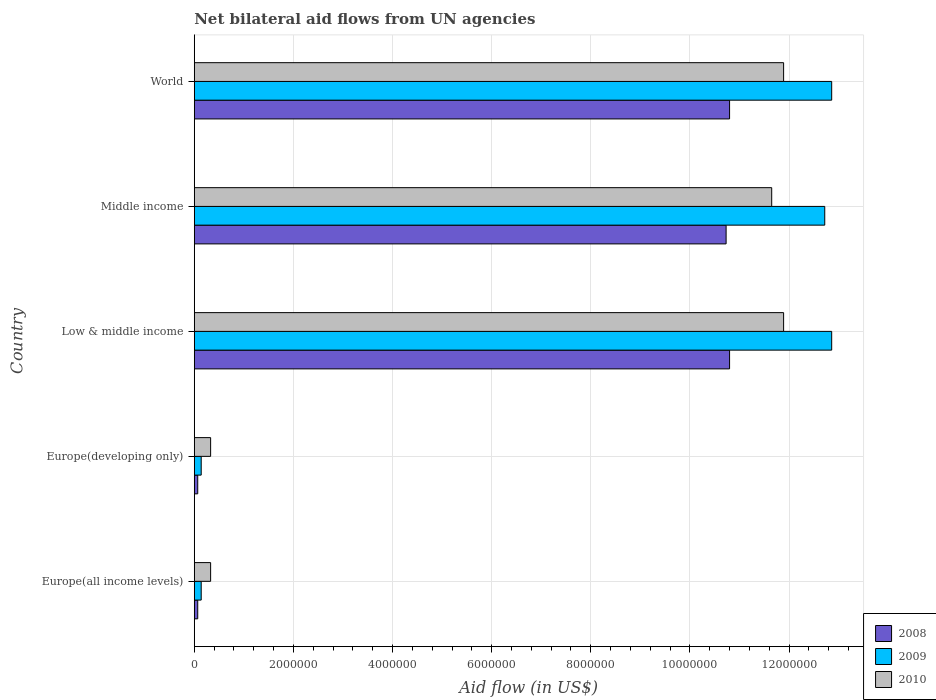Are the number of bars per tick equal to the number of legend labels?
Provide a short and direct response. Yes. How many bars are there on the 2nd tick from the top?
Offer a very short reply. 3. What is the label of the 5th group of bars from the top?
Make the answer very short. Europe(all income levels). Across all countries, what is the maximum net bilateral aid flow in 2008?
Your answer should be very brief. 1.08e+07. Across all countries, what is the minimum net bilateral aid flow in 2008?
Your answer should be very brief. 7.00e+04. In which country was the net bilateral aid flow in 2010 minimum?
Give a very brief answer. Europe(all income levels). What is the total net bilateral aid flow in 2010 in the graph?
Your answer should be very brief. 3.61e+07. What is the difference between the net bilateral aid flow in 2009 in Europe(all income levels) and that in Middle income?
Ensure brevity in your answer.  -1.26e+07. What is the difference between the net bilateral aid flow in 2010 in Middle income and the net bilateral aid flow in 2008 in Europe(all income levels)?
Your response must be concise. 1.16e+07. What is the average net bilateral aid flow in 2009 per country?
Make the answer very short. 7.74e+06. What is the ratio of the net bilateral aid flow in 2009 in Europe(all income levels) to that in World?
Provide a succinct answer. 0.01. Is the difference between the net bilateral aid flow in 2008 in Low & middle income and Middle income greater than the difference between the net bilateral aid flow in 2009 in Low & middle income and Middle income?
Your answer should be very brief. No. What is the difference between the highest and the lowest net bilateral aid flow in 2010?
Provide a succinct answer. 1.16e+07. How many bars are there?
Provide a short and direct response. 15. Are all the bars in the graph horizontal?
Your answer should be very brief. Yes. Does the graph contain grids?
Give a very brief answer. Yes. Where does the legend appear in the graph?
Your answer should be compact. Bottom right. What is the title of the graph?
Your answer should be very brief. Net bilateral aid flows from UN agencies. Does "1972" appear as one of the legend labels in the graph?
Your answer should be compact. No. What is the label or title of the X-axis?
Make the answer very short. Aid flow (in US$). What is the Aid flow (in US$) in 2008 in Europe(all income levels)?
Your answer should be very brief. 7.00e+04. What is the Aid flow (in US$) in 2009 in Europe(all income levels)?
Provide a succinct answer. 1.40e+05. What is the Aid flow (in US$) of 2010 in Europe(all income levels)?
Provide a short and direct response. 3.30e+05. What is the Aid flow (in US$) of 2008 in Europe(developing only)?
Your answer should be very brief. 7.00e+04. What is the Aid flow (in US$) in 2009 in Europe(developing only)?
Offer a terse response. 1.40e+05. What is the Aid flow (in US$) in 2008 in Low & middle income?
Keep it short and to the point. 1.08e+07. What is the Aid flow (in US$) of 2009 in Low & middle income?
Your answer should be compact. 1.29e+07. What is the Aid flow (in US$) of 2010 in Low & middle income?
Give a very brief answer. 1.19e+07. What is the Aid flow (in US$) in 2008 in Middle income?
Your answer should be very brief. 1.07e+07. What is the Aid flow (in US$) of 2009 in Middle income?
Provide a succinct answer. 1.27e+07. What is the Aid flow (in US$) in 2010 in Middle income?
Offer a very short reply. 1.16e+07. What is the Aid flow (in US$) of 2008 in World?
Provide a short and direct response. 1.08e+07. What is the Aid flow (in US$) of 2009 in World?
Provide a short and direct response. 1.29e+07. What is the Aid flow (in US$) in 2010 in World?
Your answer should be very brief. 1.19e+07. Across all countries, what is the maximum Aid flow (in US$) of 2008?
Your response must be concise. 1.08e+07. Across all countries, what is the maximum Aid flow (in US$) in 2009?
Give a very brief answer. 1.29e+07. Across all countries, what is the maximum Aid flow (in US$) in 2010?
Your answer should be compact. 1.19e+07. Across all countries, what is the minimum Aid flow (in US$) in 2008?
Make the answer very short. 7.00e+04. Across all countries, what is the minimum Aid flow (in US$) of 2010?
Make the answer very short. 3.30e+05. What is the total Aid flow (in US$) in 2008 in the graph?
Make the answer very short. 3.25e+07. What is the total Aid flow (in US$) in 2009 in the graph?
Offer a very short reply. 3.87e+07. What is the total Aid flow (in US$) of 2010 in the graph?
Your answer should be very brief. 3.61e+07. What is the difference between the Aid flow (in US$) of 2009 in Europe(all income levels) and that in Europe(developing only)?
Give a very brief answer. 0. What is the difference between the Aid flow (in US$) of 2008 in Europe(all income levels) and that in Low & middle income?
Provide a short and direct response. -1.07e+07. What is the difference between the Aid flow (in US$) in 2009 in Europe(all income levels) and that in Low & middle income?
Offer a terse response. -1.27e+07. What is the difference between the Aid flow (in US$) in 2010 in Europe(all income levels) and that in Low & middle income?
Your answer should be compact. -1.16e+07. What is the difference between the Aid flow (in US$) in 2008 in Europe(all income levels) and that in Middle income?
Give a very brief answer. -1.07e+07. What is the difference between the Aid flow (in US$) in 2009 in Europe(all income levels) and that in Middle income?
Make the answer very short. -1.26e+07. What is the difference between the Aid flow (in US$) in 2010 in Europe(all income levels) and that in Middle income?
Give a very brief answer. -1.13e+07. What is the difference between the Aid flow (in US$) in 2008 in Europe(all income levels) and that in World?
Your answer should be compact. -1.07e+07. What is the difference between the Aid flow (in US$) of 2009 in Europe(all income levels) and that in World?
Offer a very short reply. -1.27e+07. What is the difference between the Aid flow (in US$) of 2010 in Europe(all income levels) and that in World?
Ensure brevity in your answer.  -1.16e+07. What is the difference between the Aid flow (in US$) of 2008 in Europe(developing only) and that in Low & middle income?
Keep it short and to the point. -1.07e+07. What is the difference between the Aid flow (in US$) of 2009 in Europe(developing only) and that in Low & middle income?
Give a very brief answer. -1.27e+07. What is the difference between the Aid flow (in US$) of 2010 in Europe(developing only) and that in Low & middle income?
Offer a very short reply. -1.16e+07. What is the difference between the Aid flow (in US$) in 2008 in Europe(developing only) and that in Middle income?
Your answer should be compact. -1.07e+07. What is the difference between the Aid flow (in US$) in 2009 in Europe(developing only) and that in Middle income?
Ensure brevity in your answer.  -1.26e+07. What is the difference between the Aid flow (in US$) in 2010 in Europe(developing only) and that in Middle income?
Provide a short and direct response. -1.13e+07. What is the difference between the Aid flow (in US$) in 2008 in Europe(developing only) and that in World?
Keep it short and to the point. -1.07e+07. What is the difference between the Aid flow (in US$) of 2009 in Europe(developing only) and that in World?
Ensure brevity in your answer.  -1.27e+07. What is the difference between the Aid flow (in US$) in 2010 in Europe(developing only) and that in World?
Your answer should be very brief. -1.16e+07. What is the difference between the Aid flow (in US$) of 2010 in Low & middle income and that in Middle income?
Offer a terse response. 2.40e+05. What is the difference between the Aid flow (in US$) of 2009 in Low & middle income and that in World?
Make the answer very short. 0. What is the difference between the Aid flow (in US$) in 2010 in Low & middle income and that in World?
Offer a very short reply. 0. What is the difference between the Aid flow (in US$) in 2009 in Middle income and that in World?
Offer a terse response. -1.40e+05. What is the difference between the Aid flow (in US$) of 2008 in Europe(all income levels) and the Aid flow (in US$) of 2010 in Europe(developing only)?
Provide a succinct answer. -2.60e+05. What is the difference between the Aid flow (in US$) in 2009 in Europe(all income levels) and the Aid flow (in US$) in 2010 in Europe(developing only)?
Provide a short and direct response. -1.90e+05. What is the difference between the Aid flow (in US$) of 2008 in Europe(all income levels) and the Aid flow (in US$) of 2009 in Low & middle income?
Give a very brief answer. -1.28e+07. What is the difference between the Aid flow (in US$) in 2008 in Europe(all income levels) and the Aid flow (in US$) in 2010 in Low & middle income?
Your answer should be very brief. -1.18e+07. What is the difference between the Aid flow (in US$) of 2009 in Europe(all income levels) and the Aid flow (in US$) of 2010 in Low & middle income?
Give a very brief answer. -1.18e+07. What is the difference between the Aid flow (in US$) in 2008 in Europe(all income levels) and the Aid flow (in US$) in 2009 in Middle income?
Provide a succinct answer. -1.26e+07. What is the difference between the Aid flow (in US$) in 2008 in Europe(all income levels) and the Aid flow (in US$) in 2010 in Middle income?
Give a very brief answer. -1.16e+07. What is the difference between the Aid flow (in US$) of 2009 in Europe(all income levels) and the Aid flow (in US$) of 2010 in Middle income?
Provide a succinct answer. -1.15e+07. What is the difference between the Aid flow (in US$) in 2008 in Europe(all income levels) and the Aid flow (in US$) in 2009 in World?
Give a very brief answer. -1.28e+07. What is the difference between the Aid flow (in US$) in 2008 in Europe(all income levels) and the Aid flow (in US$) in 2010 in World?
Provide a short and direct response. -1.18e+07. What is the difference between the Aid flow (in US$) in 2009 in Europe(all income levels) and the Aid flow (in US$) in 2010 in World?
Your answer should be compact. -1.18e+07. What is the difference between the Aid flow (in US$) of 2008 in Europe(developing only) and the Aid flow (in US$) of 2009 in Low & middle income?
Keep it short and to the point. -1.28e+07. What is the difference between the Aid flow (in US$) in 2008 in Europe(developing only) and the Aid flow (in US$) in 2010 in Low & middle income?
Ensure brevity in your answer.  -1.18e+07. What is the difference between the Aid flow (in US$) in 2009 in Europe(developing only) and the Aid flow (in US$) in 2010 in Low & middle income?
Your answer should be very brief. -1.18e+07. What is the difference between the Aid flow (in US$) of 2008 in Europe(developing only) and the Aid flow (in US$) of 2009 in Middle income?
Keep it short and to the point. -1.26e+07. What is the difference between the Aid flow (in US$) of 2008 in Europe(developing only) and the Aid flow (in US$) of 2010 in Middle income?
Your answer should be compact. -1.16e+07. What is the difference between the Aid flow (in US$) in 2009 in Europe(developing only) and the Aid flow (in US$) in 2010 in Middle income?
Your response must be concise. -1.15e+07. What is the difference between the Aid flow (in US$) of 2008 in Europe(developing only) and the Aid flow (in US$) of 2009 in World?
Make the answer very short. -1.28e+07. What is the difference between the Aid flow (in US$) of 2008 in Europe(developing only) and the Aid flow (in US$) of 2010 in World?
Make the answer very short. -1.18e+07. What is the difference between the Aid flow (in US$) in 2009 in Europe(developing only) and the Aid flow (in US$) in 2010 in World?
Provide a succinct answer. -1.18e+07. What is the difference between the Aid flow (in US$) of 2008 in Low & middle income and the Aid flow (in US$) of 2009 in Middle income?
Your response must be concise. -1.92e+06. What is the difference between the Aid flow (in US$) of 2008 in Low & middle income and the Aid flow (in US$) of 2010 in Middle income?
Your answer should be compact. -8.50e+05. What is the difference between the Aid flow (in US$) of 2009 in Low & middle income and the Aid flow (in US$) of 2010 in Middle income?
Offer a terse response. 1.21e+06. What is the difference between the Aid flow (in US$) in 2008 in Low & middle income and the Aid flow (in US$) in 2009 in World?
Provide a succinct answer. -2.06e+06. What is the difference between the Aid flow (in US$) in 2008 in Low & middle income and the Aid flow (in US$) in 2010 in World?
Provide a succinct answer. -1.09e+06. What is the difference between the Aid flow (in US$) in 2009 in Low & middle income and the Aid flow (in US$) in 2010 in World?
Offer a terse response. 9.70e+05. What is the difference between the Aid flow (in US$) of 2008 in Middle income and the Aid flow (in US$) of 2009 in World?
Make the answer very short. -2.13e+06. What is the difference between the Aid flow (in US$) of 2008 in Middle income and the Aid flow (in US$) of 2010 in World?
Your answer should be very brief. -1.16e+06. What is the difference between the Aid flow (in US$) of 2009 in Middle income and the Aid flow (in US$) of 2010 in World?
Give a very brief answer. 8.30e+05. What is the average Aid flow (in US$) of 2008 per country?
Provide a short and direct response. 6.49e+06. What is the average Aid flow (in US$) in 2009 per country?
Your answer should be very brief. 7.74e+06. What is the average Aid flow (in US$) of 2010 per country?
Offer a very short reply. 7.22e+06. What is the difference between the Aid flow (in US$) in 2008 and Aid flow (in US$) in 2009 in Europe(all income levels)?
Offer a very short reply. -7.00e+04. What is the difference between the Aid flow (in US$) of 2008 and Aid flow (in US$) of 2010 in Europe(all income levels)?
Make the answer very short. -2.60e+05. What is the difference between the Aid flow (in US$) of 2008 and Aid flow (in US$) of 2009 in Europe(developing only)?
Your response must be concise. -7.00e+04. What is the difference between the Aid flow (in US$) of 2008 and Aid flow (in US$) of 2009 in Low & middle income?
Your answer should be very brief. -2.06e+06. What is the difference between the Aid flow (in US$) in 2008 and Aid flow (in US$) in 2010 in Low & middle income?
Your answer should be very brief. -1.09e+06. What is the difference between the Aid flow (in US$) of 2009 and Aid flow (in US$) of 2010 in Low & middle income?
Your answer should be very brief. 9.70e+05. What is the difference between the Aid flow (in US$) of 2008 and Aid flow (in US$) of 2009 in Middle income?
Offer a very short reply. -1.99e+06. What is the difference between the Aid flow (in US$) in 2008 and Aid flow (in US$) in 2010 in Middle income?
Provide a short and direct response. -9.20e+05. What is the difference between the Aid flow (in US$) of 2009 and Aid flow (in US$) of 2010 in Middle income?
Make the answer very short. 1.07e+06. What is the difference between the Aid flow (in US$) of 2008 and Aid flow (in US$) of 2009 in World?
Offer a terse response. -2.06e+06. What is the difference between the Aid flow (in US$) in 2008 and Aid flow (in US$) in 2010 in World?
Your answer should be compact. -1.09e+06. What is the difference between the Aid flow (in US$) in 2009 and Aid flow (in US$) in 2010 in World?
Your response must be concise. 9.70e+05. What is the ratio of the Aid flow (in US$) in 2010 in Europe(all income levels) to that in Europe(developing only)?
Make the answer very short. 1. What is the ratio of the Aid flow (in US$) in 2008 in Europe(all income levels) to that in Low & middle income?
Your answer should be compact. 0.01. What is the ratio of the Aid flow (in US$) in 2009 in Europe(all income levels) to that in Low & middle income?
Keep it short and to the point. 0.01. What is the ratio of the Aid flow (in US$) of 2010 in Europe(all income levels) to that in Low & middle income?
Provide a succinct answer. 0.03. What is the ratio of the Aid flow (in US$) in 2008 in Europe(all income levels) to that in Middle income?
Your response must be concise. 0.01. What is the ratio of the Aid flow (in US$) in 2009 in Europe(all income levels) to that in Middle income?
Your answer should be compact. 0.01. What is the ratio of the Aid flow (in US$) of 2010 in Europe(all income levels) to that in Middle income?
Offer a very short reply. 0.03. What is the ratio of the Aid flow (in US$) in 2008 in Europe(all income levels) to that in World?
Keep it short and to the point. 0.01. What is the ratio of the Aid flow (in US$) in 2009 in Europe(all income levels) to that in World?
Give a very brief answer. 0.01. What is the ratio of the Aid flow (in US$) of 2010 in Europe(all income levels) to that in World?
Provide a short and direct response. 0.03. What is the ratio of the Aid flow (in US$) in 2008 in Europe(developing only) to that in Low & middle income?
Make the answer very short. 0.01. What is the ratio of the Aid flow (in US$) in 2009 in Europe(developing only) to that in Low & middle income?
Your response must be concise. 0.01. What is the ratio of the Aid flow (in US$) of 2010 in Europe(developing only) to that in Low & middle income?
Keep it short and to the point. 0.03. What is the ratio of the Aid flow (in US$) of 2008 in Europe(developing only) to that in Middle income?
Give a very brief answer. 0.01. What is the ratio of the Aid flow (in US$) of 2009 in Europe(developing only) to that in Middle income?
Your response must be concise. 0.01. What is the ratio of the Aid flow (in US$) of 2010 in Europe(developing only) to that in Middle income?
Provide a succinct answer. 0.03. What is the ratio of the Aid flow (in US$) of 2008 in Europe(developing only) to that in World?
Your response must be concise. 0.01. What is the ratio of the Aid flow (in US$) in 2009 in Europe(developing only) to that in World?
Offer a terse response. 0.01. What is the ratio of the Aid flow (in US$) in 2010 in Europe(developing only) to that in World?
Give a very brief answer. 0.03. What is the ratio of the Aid flow (in US$) in 2008 in Low & middle income to that in Middle income?
Your answer should be very brief. 1.01. What is the ratio of the Aid flow (in US$) in 2010 in Low & middle income to that in Middle income?
Your response must be concise. 1.02. What is the ratio of the Aid flow (in US$) of 2010 in Low & middle income to that in World?
Make the answer very short. 1. What is the ratio of the Aid flow (in US$) of 2008 in Middle income to that in World?
Provide a succinct answer. 0.99. What is the ratio of the Aid flow (in US$) in 2009 in Middle income to that in World?
Provide a short and direct response. 0.99. What is the ratio of the Aid flow (in US$) in 2010 in Middle income to that in World?
Give a very brief answer. 0.98. What is the difference between the highest and the lowest Aid flow (in US$) in 2008?
Keep it short and to the point. 1.07e+07. What is the difference between the highest and the lowest Aid flow (in US$) in 2009?
Offer a terse response. 1.27e+07. What is the difference between the highest and the lowest Aid flow (in US$) of 2010?
Keep it short and to the point. 1.16e+07. 